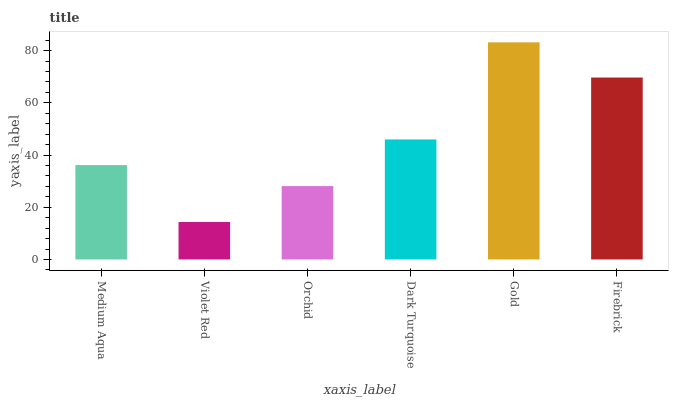Is Violet Red the minimum?
Answer yes or no. Yes. Is Gold the maximum?
Answer yes or no. Yes. Is Orchid the minimum?
Answer yes or no. No. Is Orchid the maximum?
Answer yes or no. No. Is Orchid greater than Violet Red?
Answer yes or no. Yes. Is Violet Red less than Orchid?
Answer yes or no. Yes. Is Violet Red greater than Orchid?
Answer yes or no. No. Is Orchid less than Violet Red?
Answer yes or no. No. Is Dark Turquoise the high median?
Answer yes or no. Yes. Is Medium Aqua the low median?
Answer yes or no. Yes. Is Orchid the high median?
Answer yes or no. No. Is Dark Turquoise the low median?
Answer yes or no. No. 